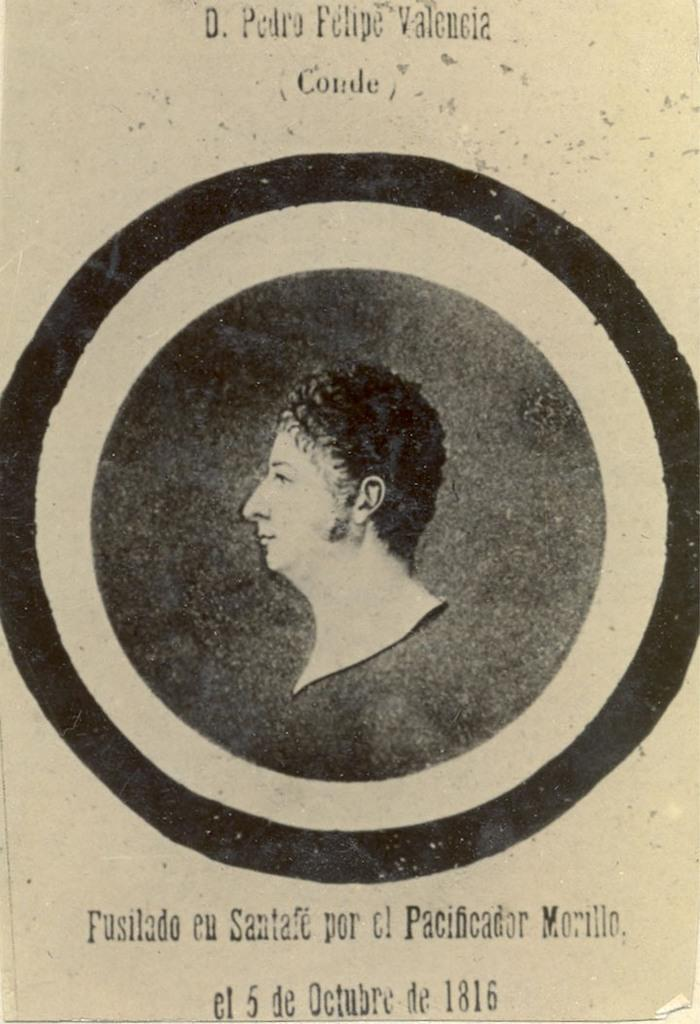What type of visual is the image? The image is a poster. Who or what is shown on the poster? There is a person depicted on the poster. Are there any words or phrases on the poster? Yes, there is text present on the poster. What color is the snake on the poster? There is no snake present on the poster; it features a person and text. How many dimes are visible on the poster? There are no dimes visible on the poster. 